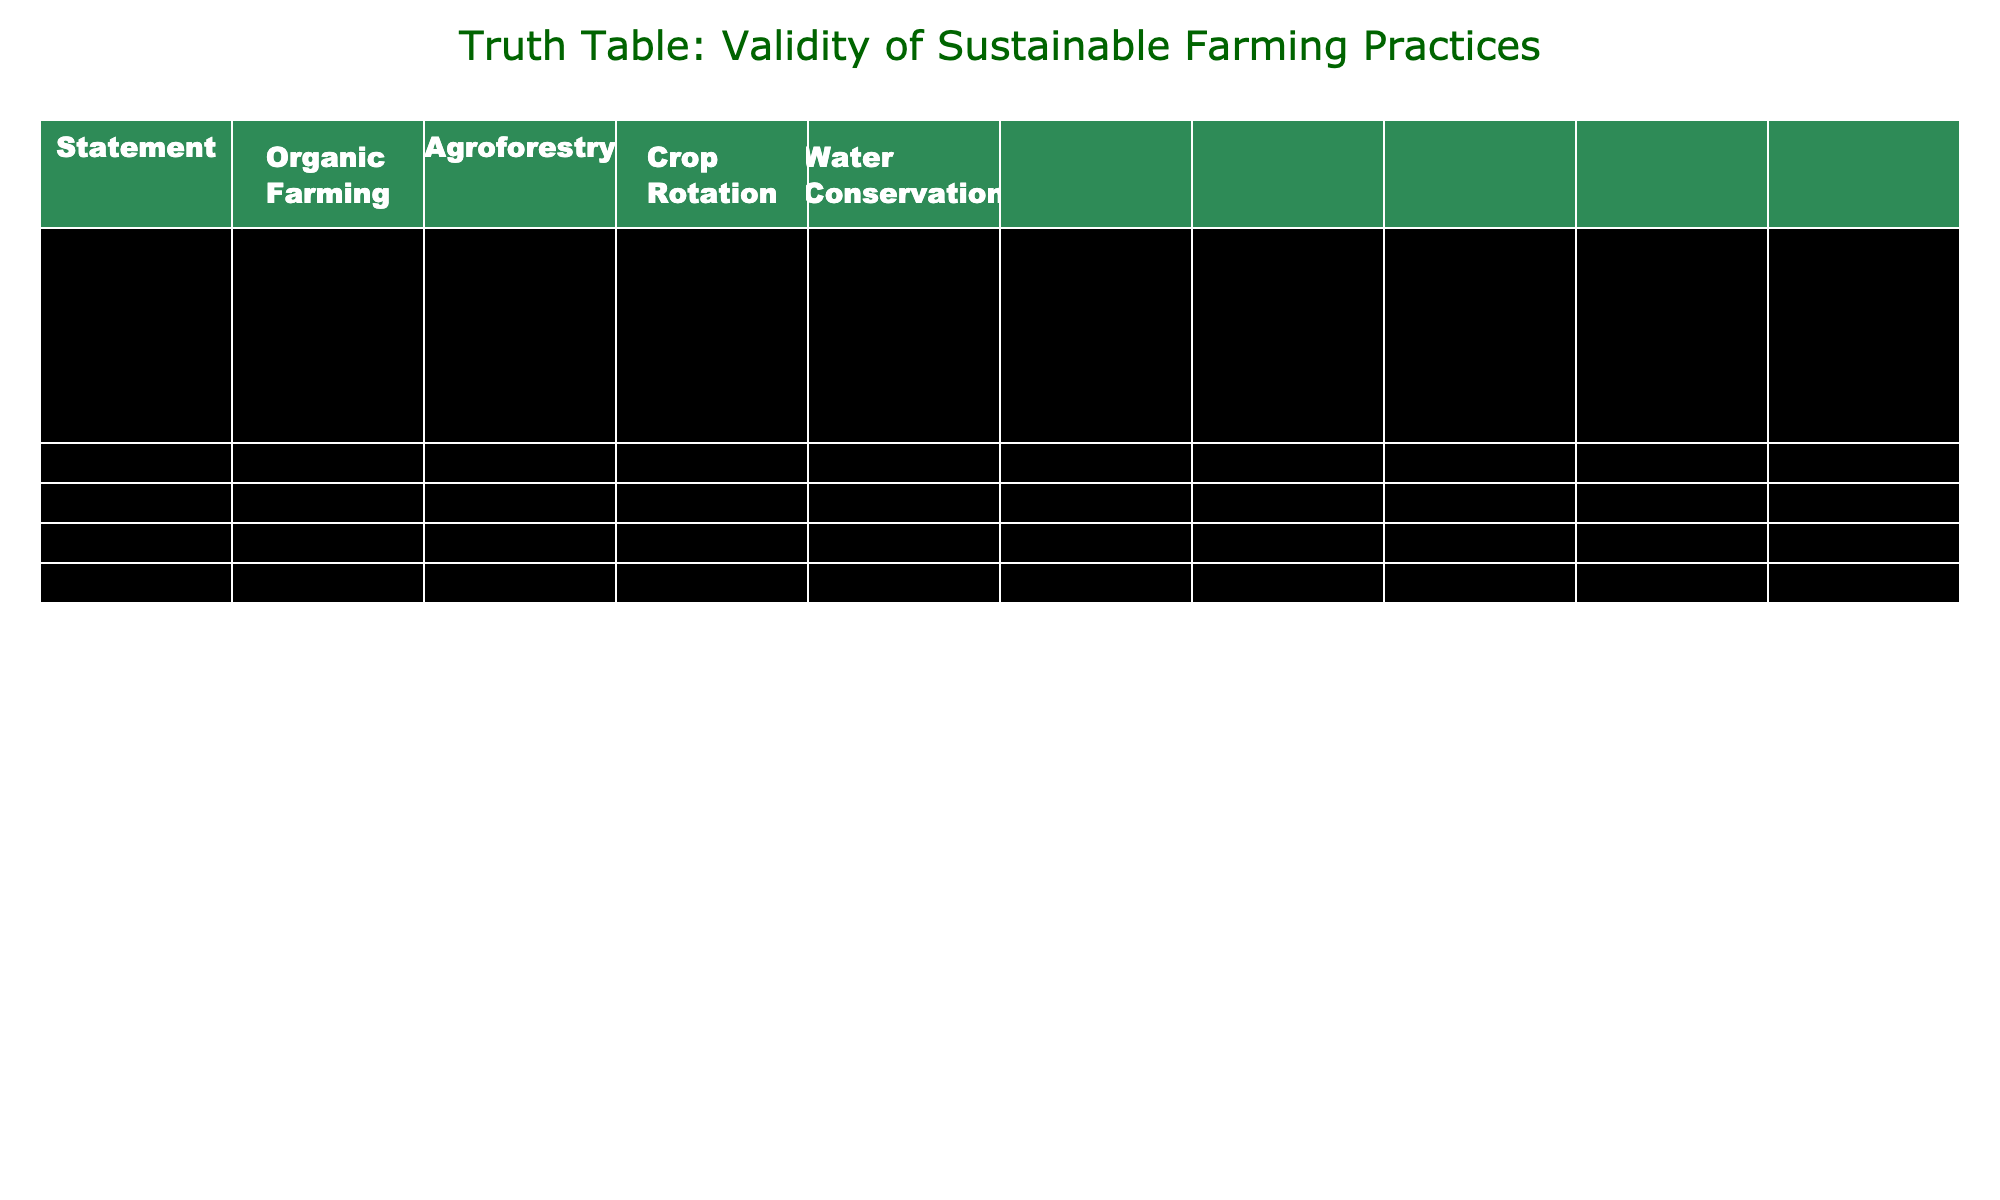What statements about organic farming are considered true? Referring to the column under organic farming, the statements with TRUE values are: "Organic farming reduces soil erosion," "Agroforestry improves biodiversity," "Crop rotation increases soil fertility," "Water conservation methods reduce water usage," "These practices preserve traditional indigenous knowledge," "These methods reduce dependency on chemical fertilizers," "Sustainable practices help mitigate climate change," and "Sustainable farming practices improve food security."
Answer: 8 statements Does agroforestry always improve biodiversity? The statement "Agroforestry improves biodiversity" has a TRUE value, meaning agroforestry is recognized for improving biodiversity. Therefore, it does not imply that it is always the case in every context, but in this table, it is considered true.
Answer: Yes What is the combined total of true statements regarding crop rotation and water conservation? Reviewing the crop rotation and water conservation columns: Crop rotation has three TRUE values, and water conservation also has four TRUE values. Adding these, we have 3 + 4 = 7.
Answer: 7 Is sustainable farming always more labor-intensive according to this table? The statement "These methods are always more labor-intensive" has a FALSE value, indicating that sustainable farming practices are not necessarily always associated with higher labor intensity based on the data in the table.
Answer: No Which sustainable farming practice has the least affirmation regarding dependency on chemical fertilizers? Looking at the dependency on chemical fertilizers across the practices, "Water Conservation" shows a FALSE value against that statement, indicating that it does not primarily focus on reducing chemical fertilizer dependency.
Answer: Water Conservation What percentage of statements about sustainable farming practices related to climate change and food security are true? There are 4 statements for climate change and all are TRUE, and similarly, the 4 statements for food security are also all TRUE. Therefore, the percentage of true statements is (4 + 4) / 8 = 100%.
Answer: 100% Which practices help mitigate climate change and their overall affirmation count? For climate change mitigation, all practices listed (Organic Farming, Agroforestry, Crop Rotation, and Water Conservation) have TRUE values. This indicates that all four are recognized for their climate mitigation benefits. Therefore, the overall affirmation count is 4.
Answer: 4 